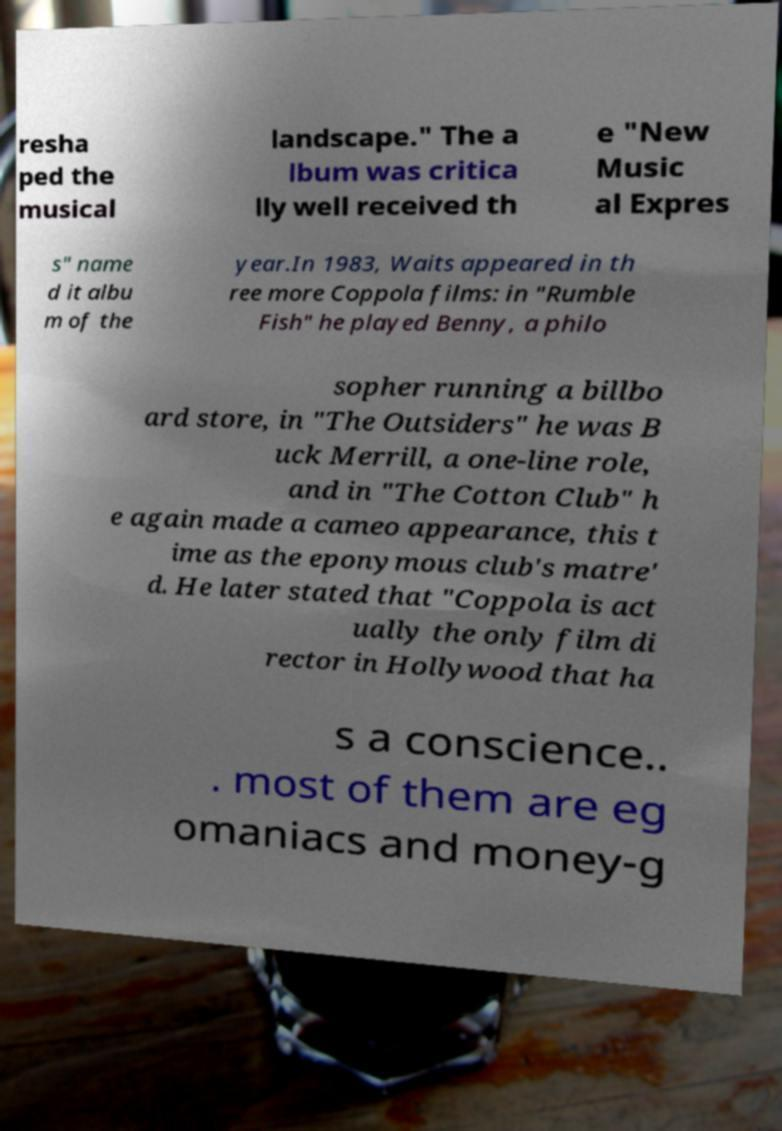What messages or text are displayed in this image? I need them in a readable, typed format. resha ped the musical landscape." The a lbum was critica lly well received th e "New Music al Expres s" name d it albu m of the year.In 1983, Waits appeared in th ree more Coppola films: in "Rumble Fish" he played Benny, a philo sopher running a billbo ard store, in "The Outsiders" he was B uck Merrill, a one-line role, and in "The Cotton Club" h e again made a cameo appearance, this t ime as the eponymous club's matre' d. He later stated that "Coppola is act ually the only film di rector in Hollywood that ha s a conscience.. . most of them are eg omaniacs and money-g 